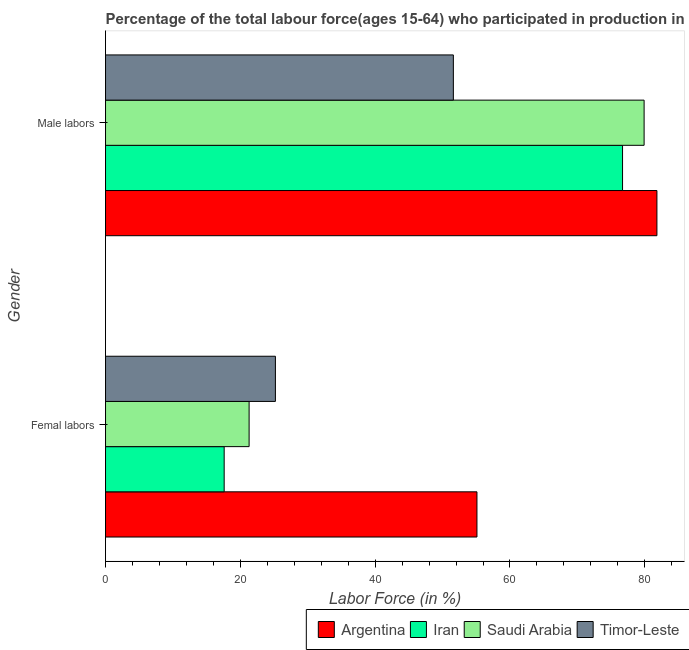How many groups of bars are there?
Your answer should be very brief. 2. Are the number of bars on each tick of the Y-axis equal?
Ensure brevity in your answer.  Yes. How many bars are there on the 2nd tick from the bottom?
Offer a very short reply. 4. What is the label of the 1st group of bars from the top?
Your answer should be very brief. Male labors. What is the percentage of male labour force in Timor-Leste?
Provide a short and direct response. 51.6. Across all countries, what is the maximum percentage of female labor force?
Offer a terse response. 55.1. Across all countries, what is the minimum percentage of female labor force?
Keep it short and to the point. 17.6. In which country was the percentage of male labour force maximum?
Keep it short and to the point. Argentina. In which country was the percentage of female labor force minimum?
Your response must be concise. Iran. What is the total percentage of male labour force in the graph?
Ensure brevity in your answer.  290. What is the difference between the percentage of female labor force in Timor-Leste and that in Iran?
Keep it short and to the point. 7.6. What is the difference between the percentage of female labor force in Timor-Leste and the percentage of male labour force in Saudi Arabia?
Your answer should be compact. -54.7. What is the average percentage of male labour force per country?
Your response must be concise. 72.5. What is the difference between the percentage of female labor force and percentage of male labour force in Argentina?
Make the answer very short. -26.7. What is the ratio of the percentage of female labor force in Argentina to that in Iran?
Provide a short and direct response. 3.13. Is the percentage of female labor force in Timor-Leste less than that in Saudi Arabia?
Ensure brevity in your answer.  No. What does the 4th bar from the top in Male labors represents?
Keep it short and to the point. Argentina. What does the 1st bar from the bottom in Male labors represents?
Offer a terse response. Argentina. How many bars are there?
Your response must be concise. 8. Are all the bars in the graph horizontal?
Your answer should be compact. Yes. Are the values on the major ticks of X-axis written in scientific E-notation?
Make the answer very short. No. Where does the legend appear in the graph?
Provide a succinct answer. Bottom right. How are the legend labels stacked?
Your answer should be compact. Horizontal. What is the title of the graph?
Keep it short and to the point. Percentage of the total labour force(ages 15-64) who participated in production in 2013. What is the Labor Force (in %) in Argentina in Femal labors?
Your answer should be compact. 55.1. What is the Labor Force (in %) of Iran in Femal labors?
Provide a short and direct response. 17.6. What is the Labor Force (in %) in Saudi Arabia in Femal labors?
Provide a short and direct response. 21.3. What is the Labor Force (in %) in Timor-Leste in Femal labors?
Give a very brief answer. 25.2. What is the Labor Force (in %) of Argentina in Male labors?
Provide a short and direct response. 81.8. What is the Labor Force (in %) of Iran in Male labors?
Offer a terse response. 76.7. What is the Labor Force (in %) in Saudi Arabia in Male labors?
Make the answer very short. 79.9. What is the Labor Force (in %) of Timor-Leste in Male labors?
Keep it short and to the point. 51.6. Across all Gender, what is the maximum Labor Force (in %) of Argentina?
Give a very brief answer. 81.8. Across all Gender, what is the maximum Labor Force (in %) in Iran?
Provide a short and direct response. 76.7. Across all Gender, what is the maximum Labor Force (in %) in Saudi Arabia?
Keep it short and to the point. 79.9. Across all Gender, what is the maximum Labor Force (in %) in Timor-Leste?
Your answer should be compact. 51.6. Across all Gender, what is the minimum Labor Force (in %) in Argentina?
Offer a very short reply. 55.1. Across all Gender, what is the minimum Labor Force (in %) in Iran?
Offer a very short reply. 17.6. Across all Gender, what is the minimum Labor Force (in %) in Saudi Arabia?
Your answer should be very brief. 21.3. Across all Gender, what is the minimum Labor Force (in %) in Timor-Leste?
Offer a terse response. 25.2. What is the total Labor Force (in %) of Argentina in the graph?
Your answer should be compact. 136.9. What is the total Labor Force (in %) of Iran in the graph?
Ensure brevity in your answer.  94.3. What is the total Labor Force (in %) in Saudi Arabia in the graph?
Give a very brief answer. 101.2. What is the total Labor Force (in %) in Timor-Leste in the graph?
Your response must be concise. 76.8. What is the difference between the Labor Force (in %) in Argentina in Femal labors and that in Male labors?
Offer a terse response. -26.7. What is the difference between the Labor Force (in %) of Iran in Femal labors and that in Male labors?
Your answer should be compact. -59.1. What is the difference between the Labor Force (in %) in Saudi Arabia in Femal labors and that in Male labors?
Provide a succinct answer. -58.6. What is the difference between the Labor Force (in %) of Timor-Leste in Femal labors and that in Male labors?
Provide a succinct answer. -26.4. What is the difference between the Labor Force (in %) in Argentina in Femal labors and the Labor Force (in %) in Iran in Male labors?
Your response must be concise. -21.6. What is the difference between the Labor Force (in %) of Argentina in Femal labors and the Labor Force (in %) of Saudi Arabia in Male labors?
Offer a very short reply. -24.8. What is the difference between the Labor Force (in %) of Argentina in Femal labors and the Labor Force (in %) of Timor-Leste in Male labors?
Offer a very short reply. 3.5. What is the difference between the Labor Force (in %) of Iran in Femal labors and the Labor Force (in %) of Saudi Arabia in Male labors?
Provide a succinct answer. -62.3. What is the difference between the Labor Force (in %) in Iran in Femal labors and the Labor Force (in %) in Timor-Leste in Male labors?
Ensure brevity in your answer.  -34. What is the difference between the Labor Force (in %) in Saudi Arabia in Femal labors and the Labor Force (in %) in Timor-Leste in Male labors?
Offer a terse response. -30.3. What is the average Labor Force (in %) in Argentina per Gender?
Keep it short and to the point. 68.45. What is the average Labor Force (in %) in Iran per Gender?
Your answer should be compact. 47.15. What is the average Labor Force (in %) of Saudi Arabia per Gender?
Offer a very short reply. 50.6. What is the average Labor Force (in %) of Timor-Leste per Gender?
Make the answer very short. 38.4. What is the difference between the Labor Force (in %) in Argentina and Labor Force (in %) in Iran in Femal labors?
Give a very brief answer. 37.5. What is the difference between the Labor Force (in %) of Argentina and Labor Force (in %) of Saudi Arabia in Femal labors?
Your response must be concise. 33.8. What is the difference between the Labor Force (in %) in Argentina and Labor Force (in %) in Timor-Leste in Femal labors?
Your answer should be very brief. 29.9. What is the difference between the Labor Force (in %) of Argentina and Labor Force (in %) of Iran in Male labors?
Your answer should be very brief. 5.1. What is the difference between the Labor Force (in %) of Argentina and Labor Force (in %) of Saudi Arabia in Male labors?
Your answer should be compact. 1.9. What is the difference between the Labor Force (in %) in Argentina and Labor Force (in %) in Timor-Leste in Male labors?
Your answer should be very brief. 30.2. What is the difference between the Labor Force (in %) in Iran and Labor Force (in %) in Saudi Arabia in Male labors?
Keep it short and to the point. -3.2. What is the difference between the Labor Force (in %) in Iran and Labor Force (in %) in Timor-Leste in Male labors?
Your answer should be compact. 25.1. What is the difference between the Labor Force (in %) in Saudi Arabia and Labor Force (in %) in Timor-Leste in Male labors?
Provide a succinct answer. 28.3. What is the ratio of the Labor Force (in %) of Argentina in Femal labors to that in Male labors?
Ensure brevity in your answer.  0.67. What is the ratio of the Labor Force (in %) of Iran in Femal labors to that in Male labors?
Offer a very short reply. 0.23. What is the ratio of the Labor Force (in %) of Saudi Arabia in Femal labors to that in Male labors?
Offer a terse response. 0.27. What is the ratio of the Labor Force (in %) of Timor-Leste in Femal labors to that in Male labors?
Your answer should be compact. 0.49. What is the difference between the highest and the second highest Labor Force (in %) of Argentina?
Ensure brevity in your answer.  26.7. What is the difference between the highest and the second highest Labor Force (in %) in Iran?
Make the answer very short. 59.1. What is the difference between the highest and the second highest Labor Force (in %) in Saudi Arabia?
Your answer should be compact. 58.6. What is the difference between the highest and the second highest Labor Force (in %) of Timor-Leste?
Ensure brevity in your answer.  26.4. What is the difference between the highest and the lowest Labor Force (in %) of Argentina?
Give a very brief answer. 26.7. What is the difference between the highest and the lowest Labor Force (in %) in Iran?
Ensure brevity in your answer.  59.1. What is the difference between the highest and the lowest Labor Force (in %) of Saudi Arabia?
Give a very brief answer. 58.6. What is the difference between the highest and the lowest Labor Force (in %) of Timor-Leste?
Your answer should be compact. 26.4. 